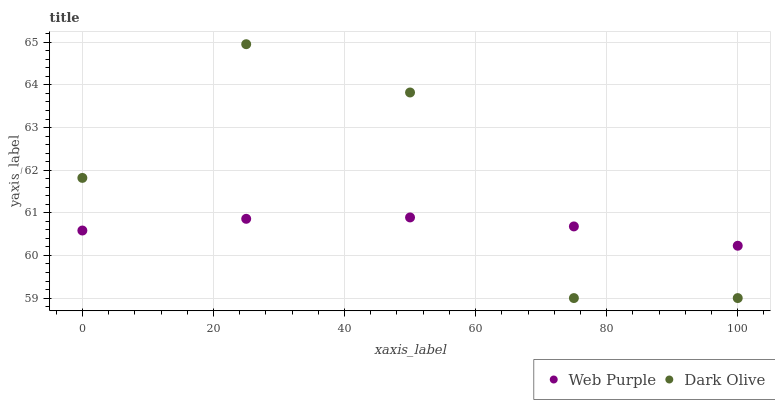Does Web Purple have the minimum area under the curve?
Answer yes or no. Yes. Does Dark Olive have the maximum area under the curve?
Answer yes or no. Yes. Does Dark Olive have the minimum area under the curve?
Answer yes or no. No. Is Web Purple the smoothest?
Answer yes or no. Yes. Is Dark Olive the roughest?
Answer yes or no. Yes. Is Dark Olive the smoothest?
Answer yes or no. No. Does Dark Olive have the lowest value?
Answer yes or no. Yes. Does Dark Olive have the highest value?
Answer yes or no. Yes. Does Dark Olive intersect Web Purple?
Answer yes or no. Yes. Is Dark Olive less than Web Purple?
Answer yes or no. No. Is Dark Olive greater than Web Purple?
Answer yes or no. No. 